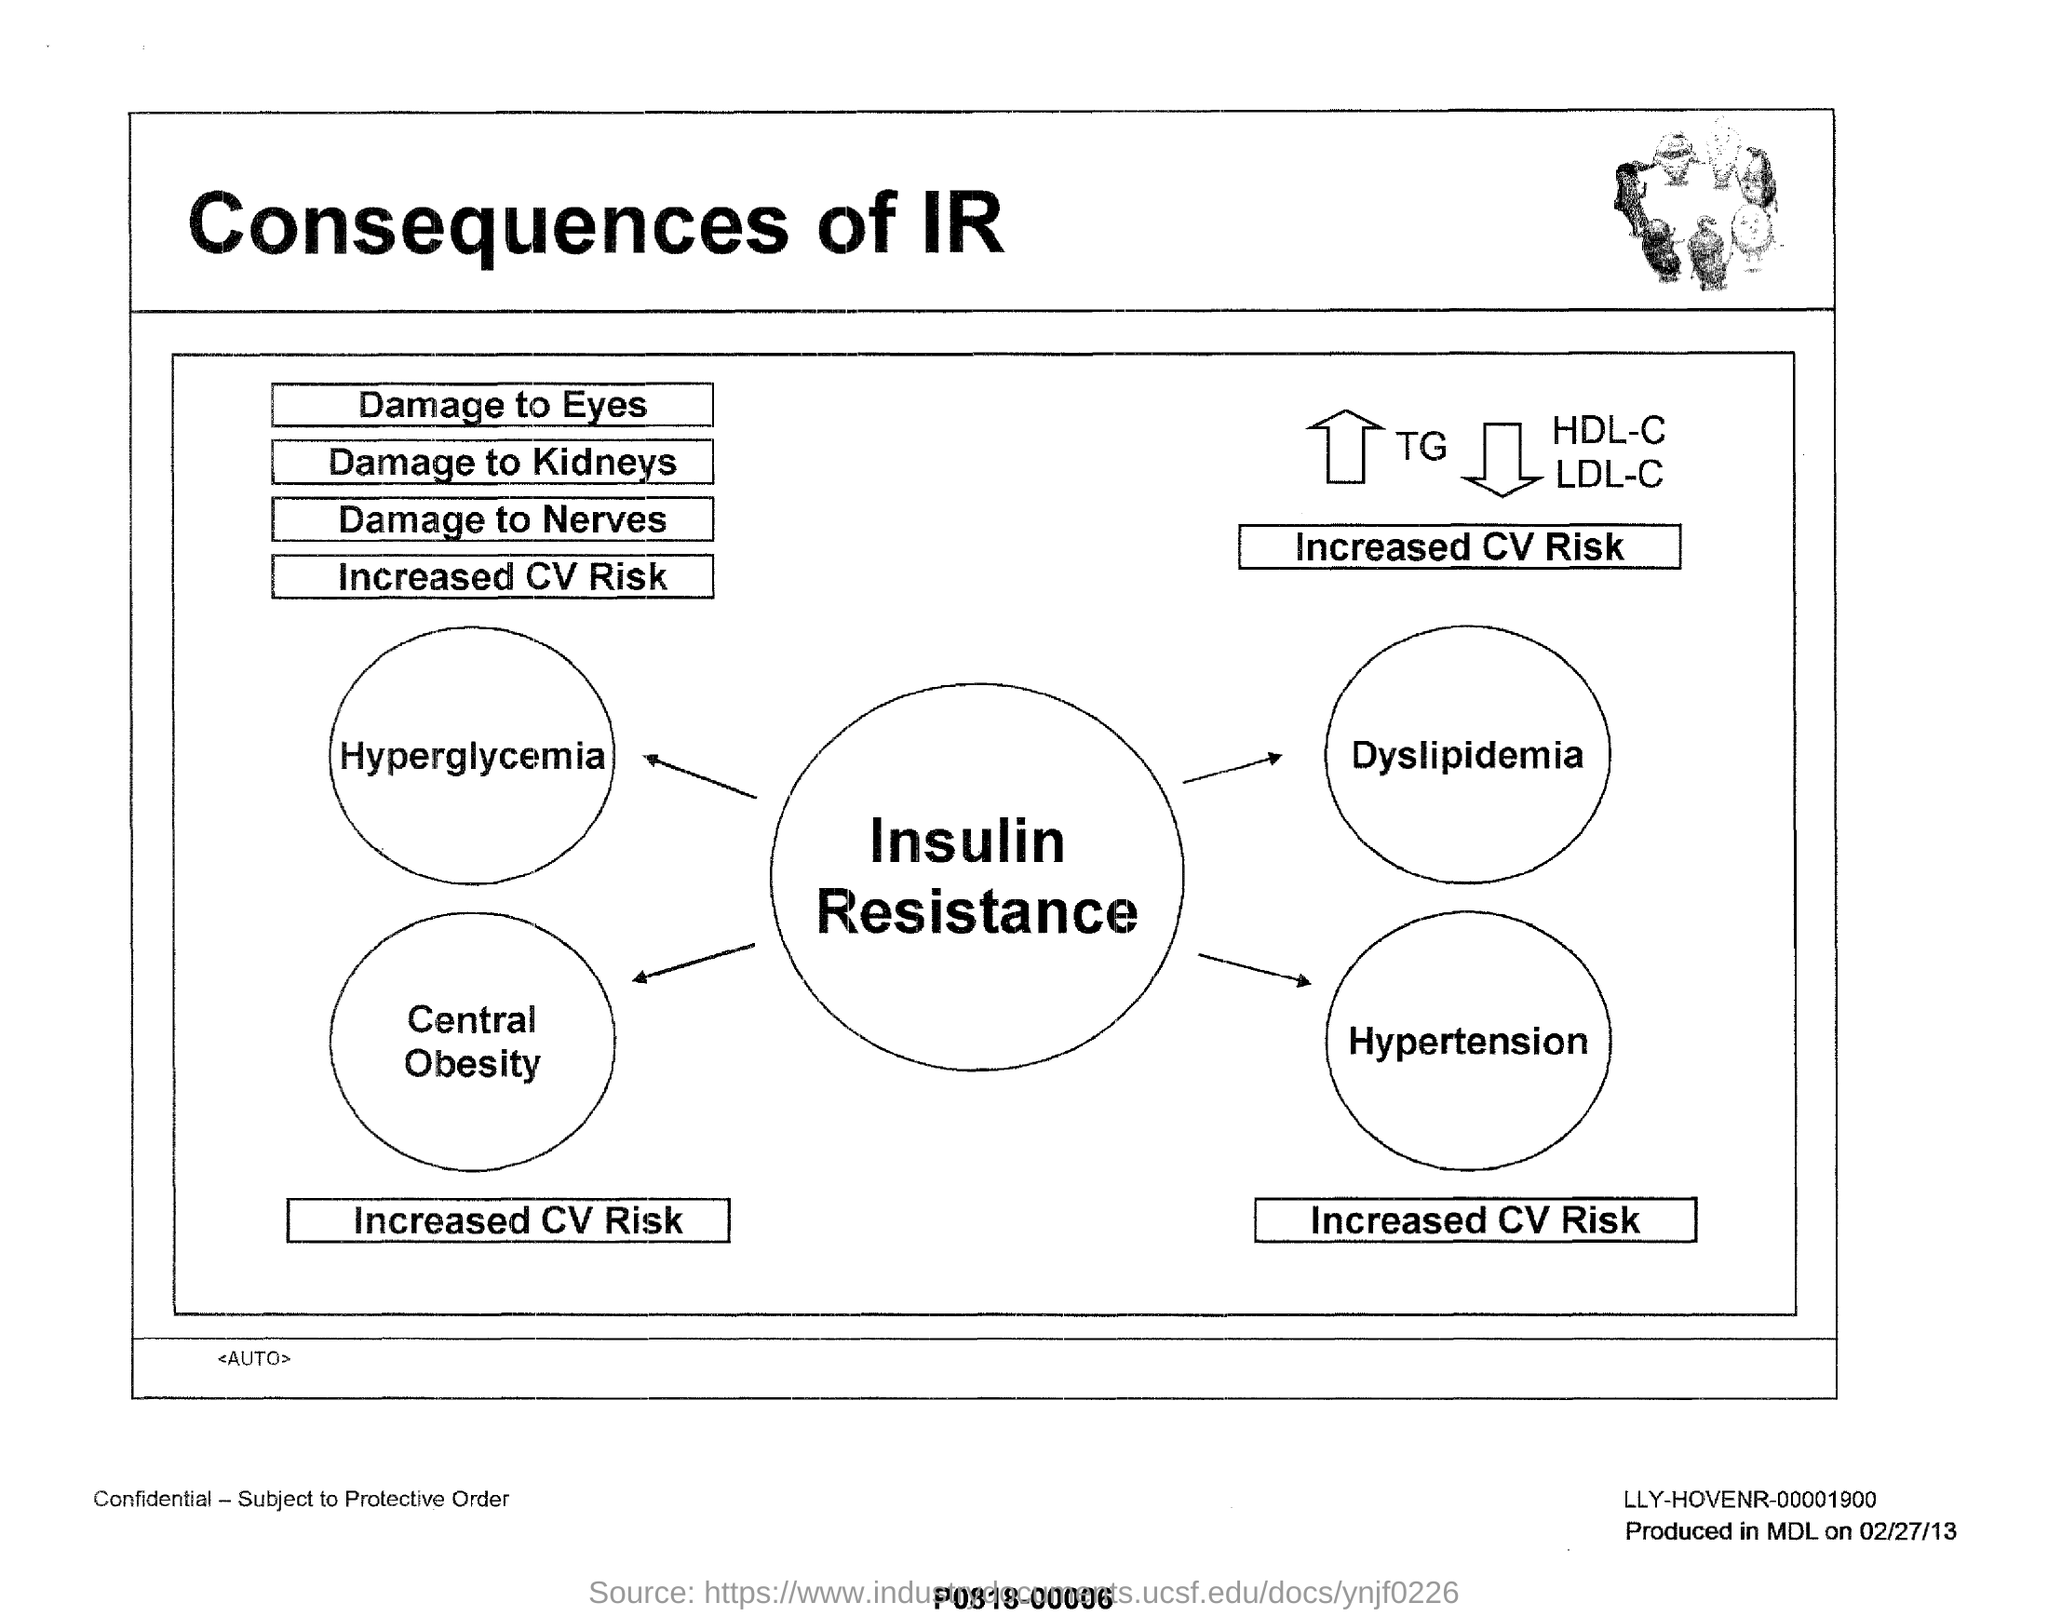Specify some key components in this picture. This document bears the title 'Consequences of IR'. 